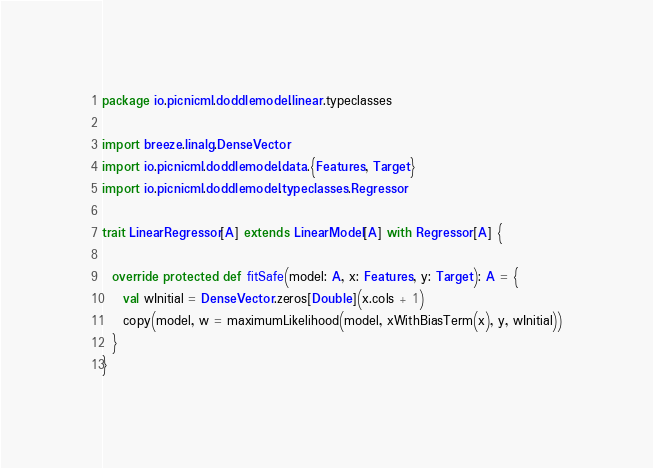<code> <loc_0><loc_0><loc_500><loc_500><_Scala_>package io.picnicml.doddlemodel.linear.typeclasses

import breeze.linalg.DenseVector
import io.picnicml.doddlemodel.data.{Features, Target}
import io.picnicml.doddlemodel.typeclasses.Regressor

trait LinearRegressor[A] extends LinearModel[A] with Regressor[A] {

  override protected def fitSafe(model: A, x: Features, y: Target): A = {
    val wInitial = DenseVector.zeros[Double](x.cols + 1)
    copy(model, w = maximumLikelihood(model, xWithBiasTerm(x), y, wInitial))
  }
}
</code> 